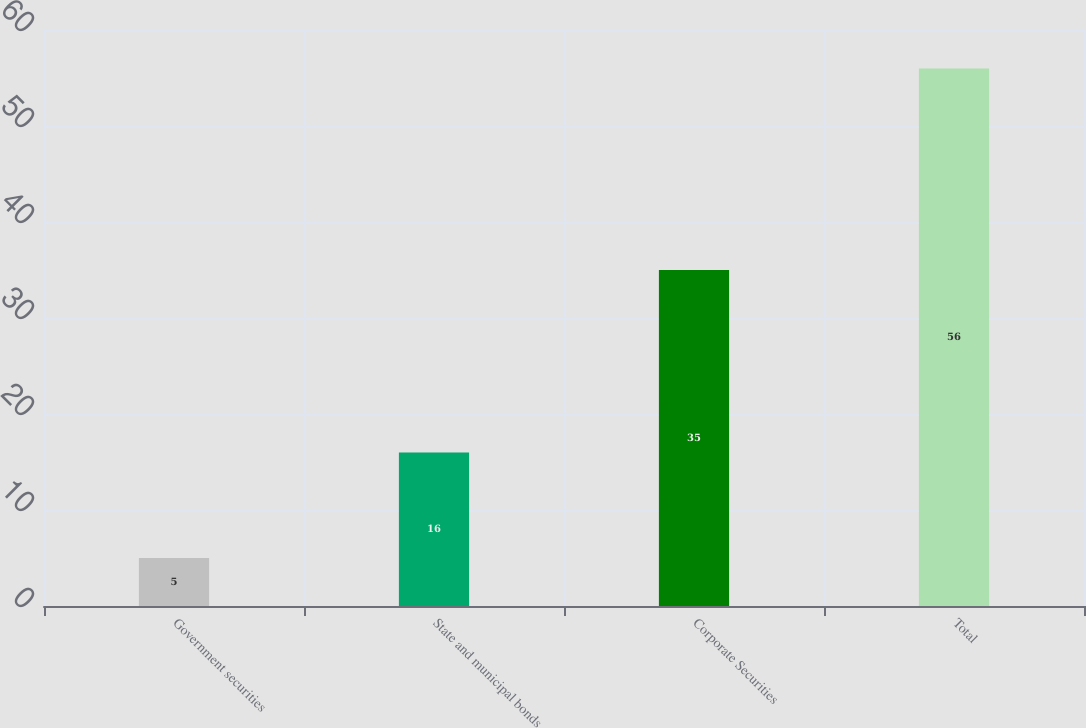<chart> <loc_0><loc_0><loc_500><loc_500><bar_chart><fcel>Government securities<fcel>State and municipal bonds<fcel>Corporate Securities<fcel>Total<nl><fcel>5<fcel>16<fcel>35<fcel>56<nl></chart> 